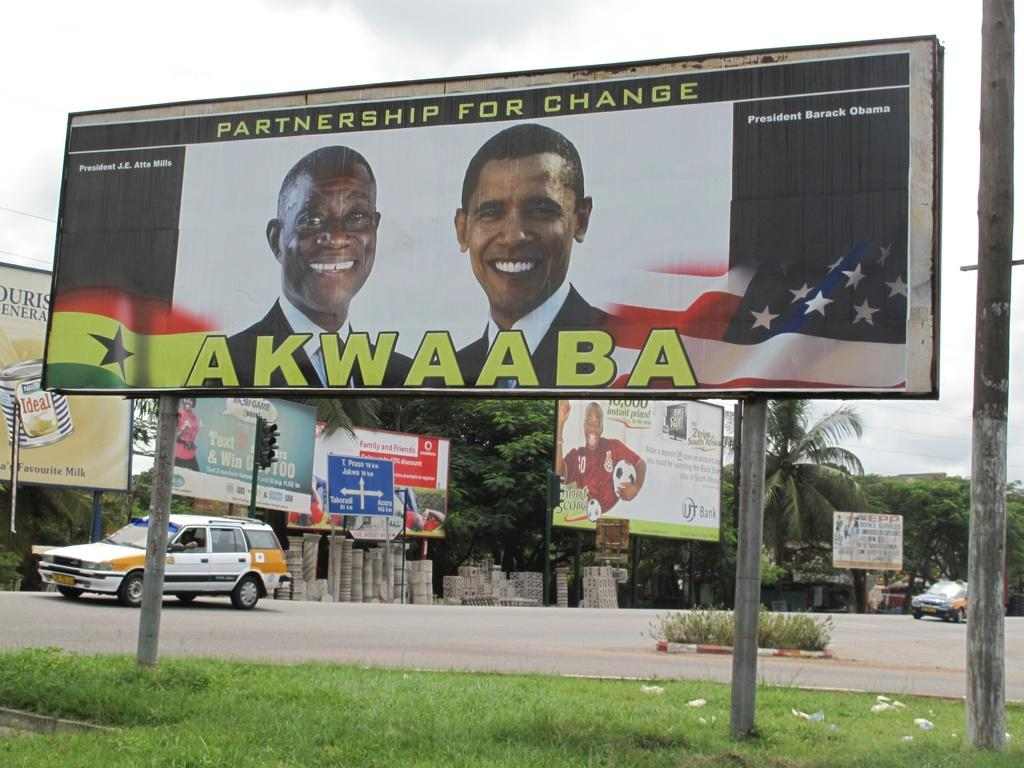<image>
Give a short and clear explanation of the subsequent image. A billboard is titled, "Partnership for Change" written in yellow letters. 